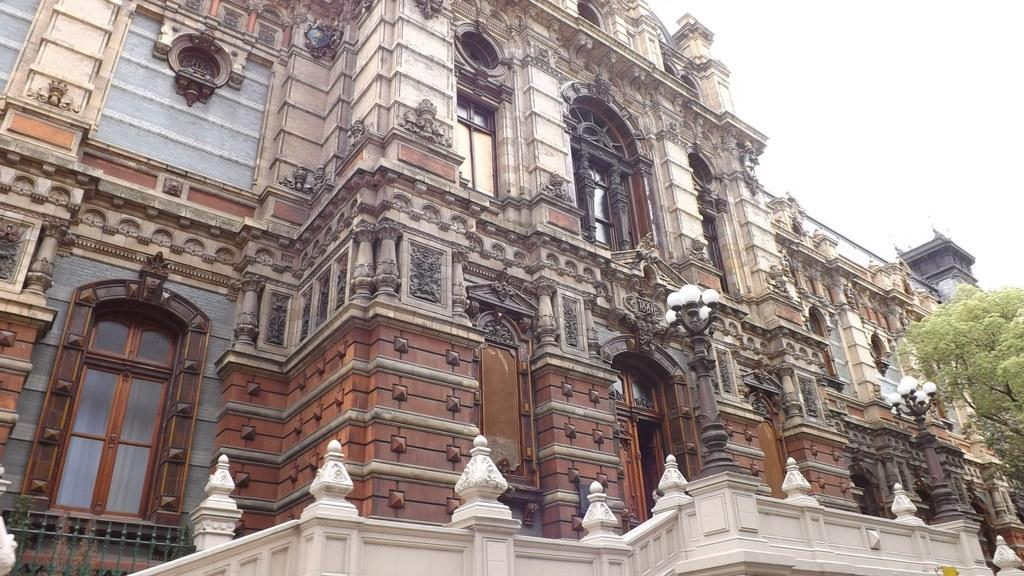What type of structures can be seen in the image? There are buildings in the image. What artistic elements are present in the image? There are sculptures in the image. What architectural features can be observed in the buildings? There are windows in the image. What type of vegetation is visible in the image? There are trees in the image. What type of lighting is present in the image? There are street lights in the image. What type of poles are present in the image? There are street poles in the image. What part of the natural environment is visible in the image? The sky is visible in the image. Can you hear the baby's cough in the image? There is no audio or indication of a baby or coughing in the image. What type of fight is taking place in the image? There is no fight or any indication of conflict in the image. 